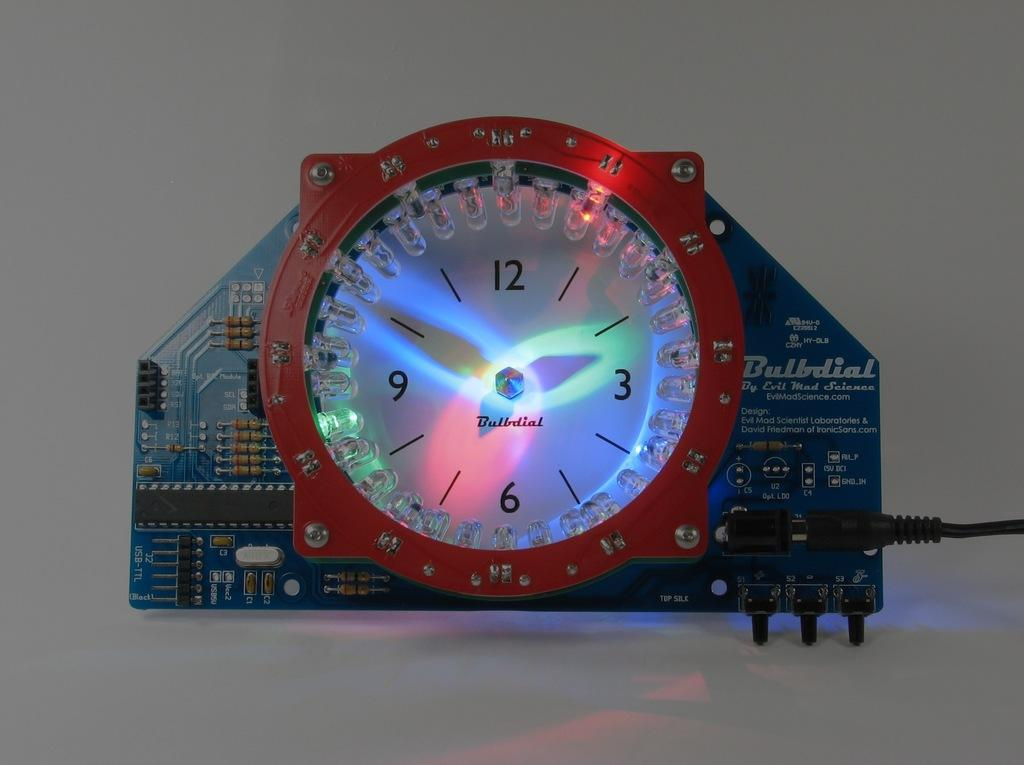<image>
Write a terse but informative summary of the picture. A Bulbdial clock has bright lights on the face. 